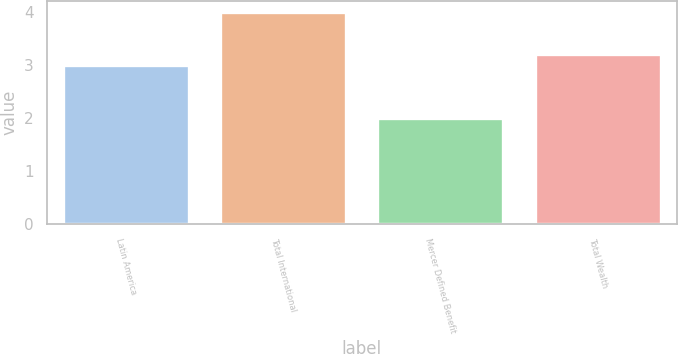Convert chart to OTSL. <chart><loc_0><loc_0><loc_500><loc_500><bar_chart><fcel>Latin America<fcel>Total International<fcel>Mercer Defined Benefit<fcel>Total Wealth<nl><fcel>3<fcel>4<fcel>2<fcel>3.2<nl></chart> 